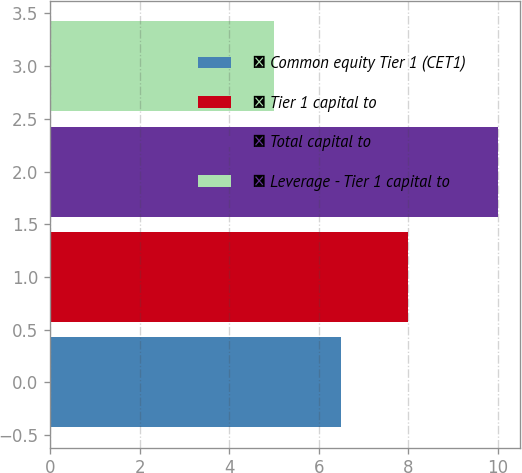Convert chart. <chart><loc_0><loc_0><loc_500><loc_500><bar_chart><fcel>● Common equity Tier 1 (CET1)<fcel>● Tier 1 capital to<fcel>● Total capital to<fcel>● Leverage - Tier 1 capital to<nl><fcel>6.5<fcel>8<fcel>10<fcel>5<nl></chart> 